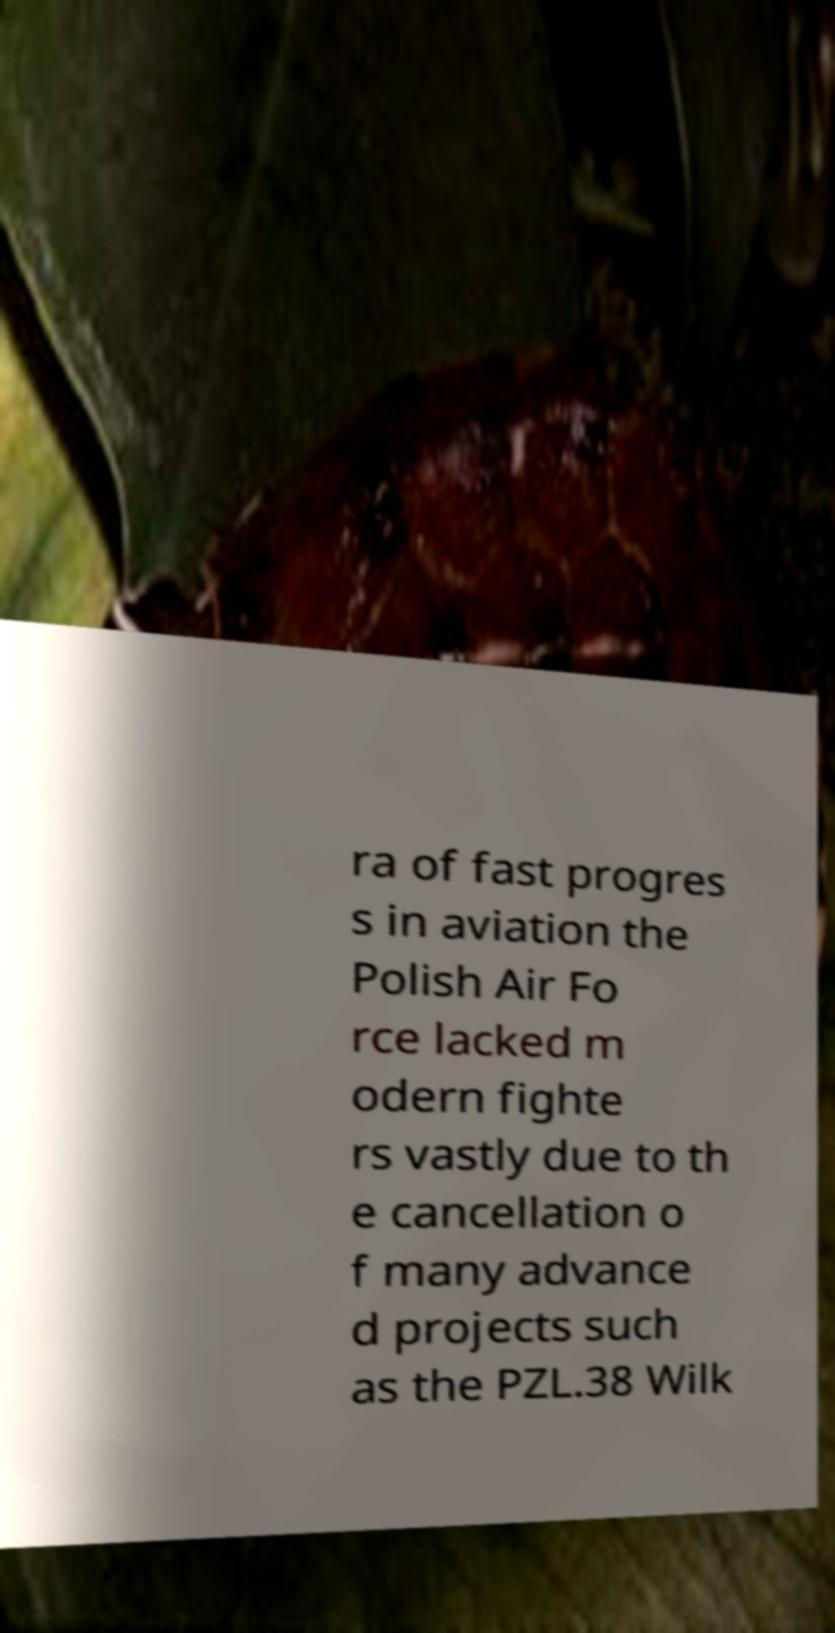Could you assist in decoding the text presented in this image and type it out clearly? ra of fast progres s in aviation the Polish Air Fo rce lacked m odern fighte rs vastly due to th e cancellation o f many advance d projects such as the PZL.38 Wilk 